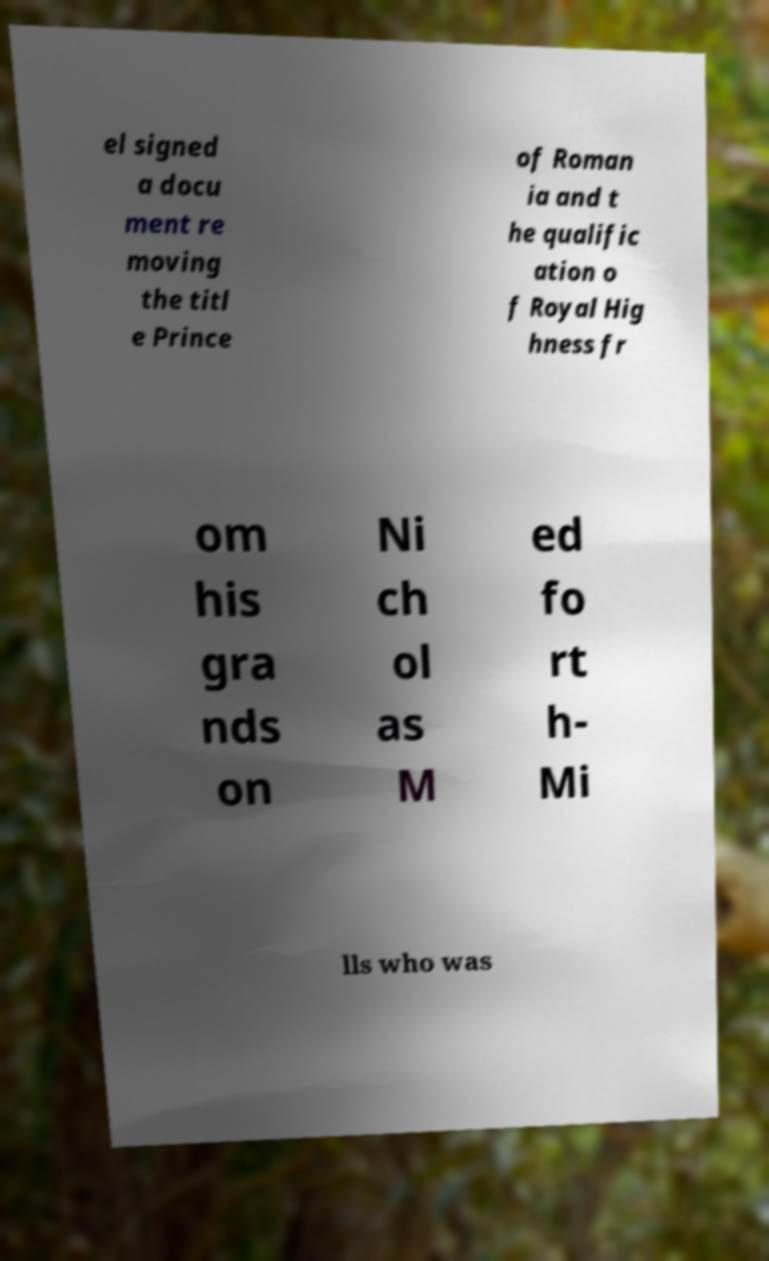Please read and relay the text visible in this image. What does it say? el signed a docu ment re moving the titl e Prince of Roman ia and t he qualific ation o f Royal Hig hness fr om his gra nds on Ni ch ol as M ed fo rt h- Mi lls who was 